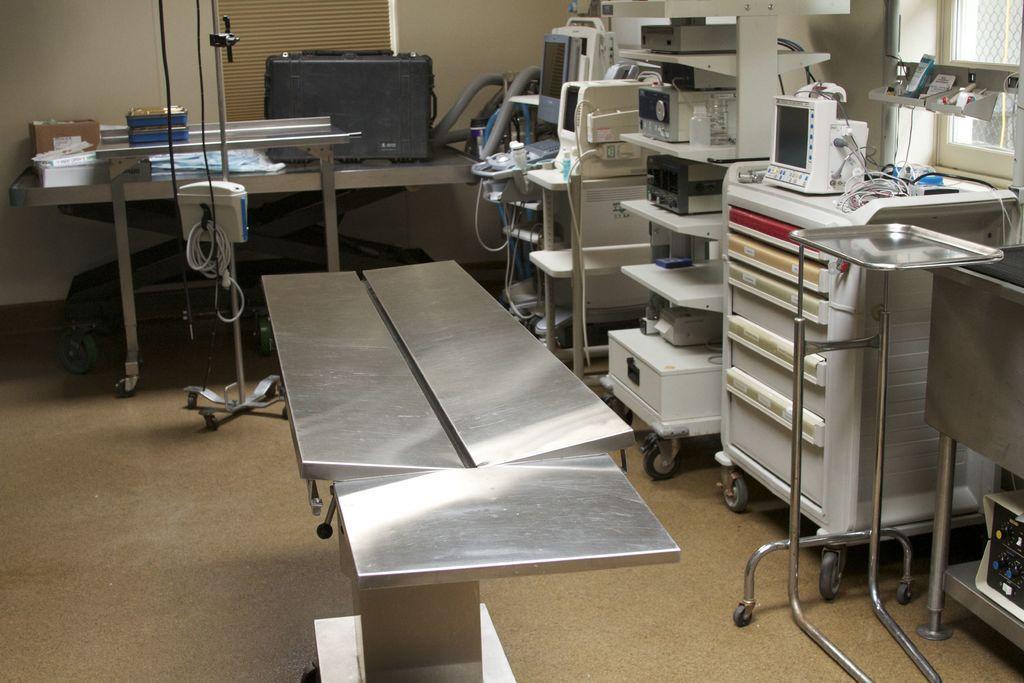In one or two sentences, can you explain what this image depicts? In this picture we can see table, stand and floor. We can see equipments and devices in racks. In the background of the image we can see box and objects on the table, wall and window blind, in front of the table we can see box and cable on stand. On the right side of the image we can see objects on the platform and window. 